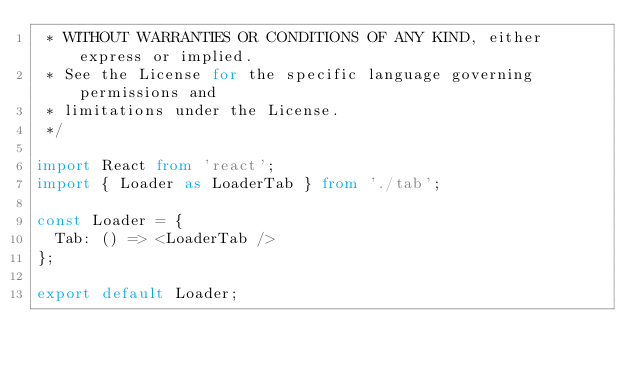<code> <loc_0><loc_0><loc_500><loc_500><_TypeScript_> * WITHOUT WARRANTIES OR CONDITIONS OF ANY KIND, either express or implied.
 * See the License for the specific language governing permissions and
 * limitations under the License.
 */

import React from 'react';
import { Loader as LoaderTab } from './tab';

const Loader = {
  Tab: () => <LoaderTab />
};

export default Loader;
</code> 